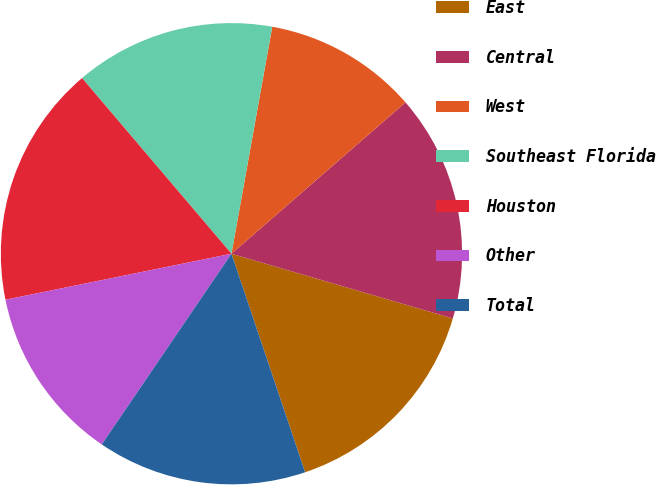Convert chart. <chart><loc_0><loc_0><loc_500><loc_500><pie_chart><fcel>East<fcel>Central<fcel>West<fcel>Southeast Florida<fcel>Houston<fcel>Other<fcel>Total<nl><fcel>15.3%<fcel>15.92%<fcel>10.78%<fcel>14.05%<fcel>16.98%<fcel>12.3%<fcel>14.68%<nl></chart> 